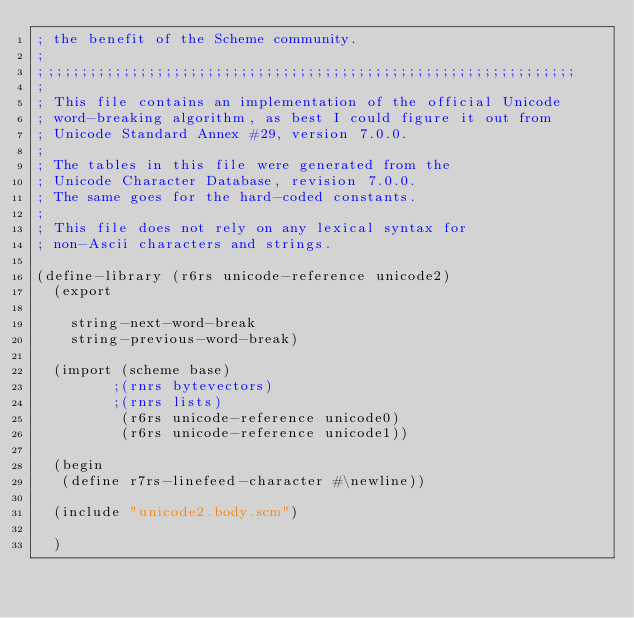<code> <loc_0><loc_0><loc_500><loc_500><_Scheme_>; the benefit of the Scheme community.
;
;;;;;;;;;;;;;;;;;;;;;;;;;;;;;;;;;;;;;;;;;;;;;;;;;;;;;;;;;;;;;;;;
;
; This file contains an implementation of the official Unicode
; word-breaking algorithm, as best I could figure it out from
; Unicode Standard Annex #29, version 7.0.0.
;
; The tables in this file were generated from the
; Unicode Character Database, revision 7.0.0.
; The same goes for the hard-coded constants.
;
; This file does not rely on any lexical syntax for
; non-Ascii characters and strings.

(define-library (r6rs unicode-reference unicode2)
  (export

    string-next-word-break
    string-previous-word-break)

  (import (scheme base)
         ;(rnrs bytevectors)
         ;(rnrs lists)
          (r6rs unicode-reference unicode0)
          (r6rs unicode-reference unicode1))

  (begin
   (define r7rs-linefeed-character #\newline))

  (include "unicode2.body.scm")

  )
</code> 